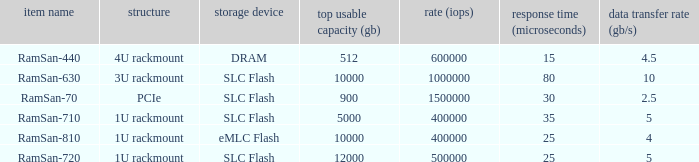List the range distroration for the ramsan-630 3U rackmount. 